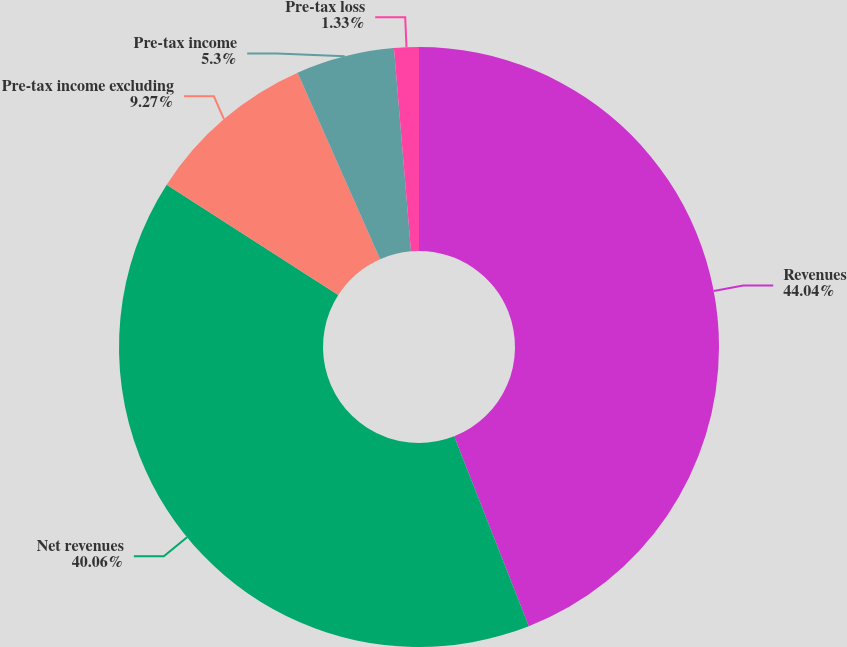<chart> <loc_0><loc_0><loc_500><loc_500><pie_chart><fcel>Revenues<fcel>Net revenues<fcel>Pre-tax income excluding<fcel>Pre-tax income<fcel>Pre-tax loss<nl><fcel>44.03%<fcel>40.06%<fcel>9.27%<fcel>5.3%<fcel>1.33%<nl></chart> 